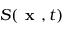<formula> <loc_0><loc_0><loc_500><loc_500>S ( x , t )</formula> 